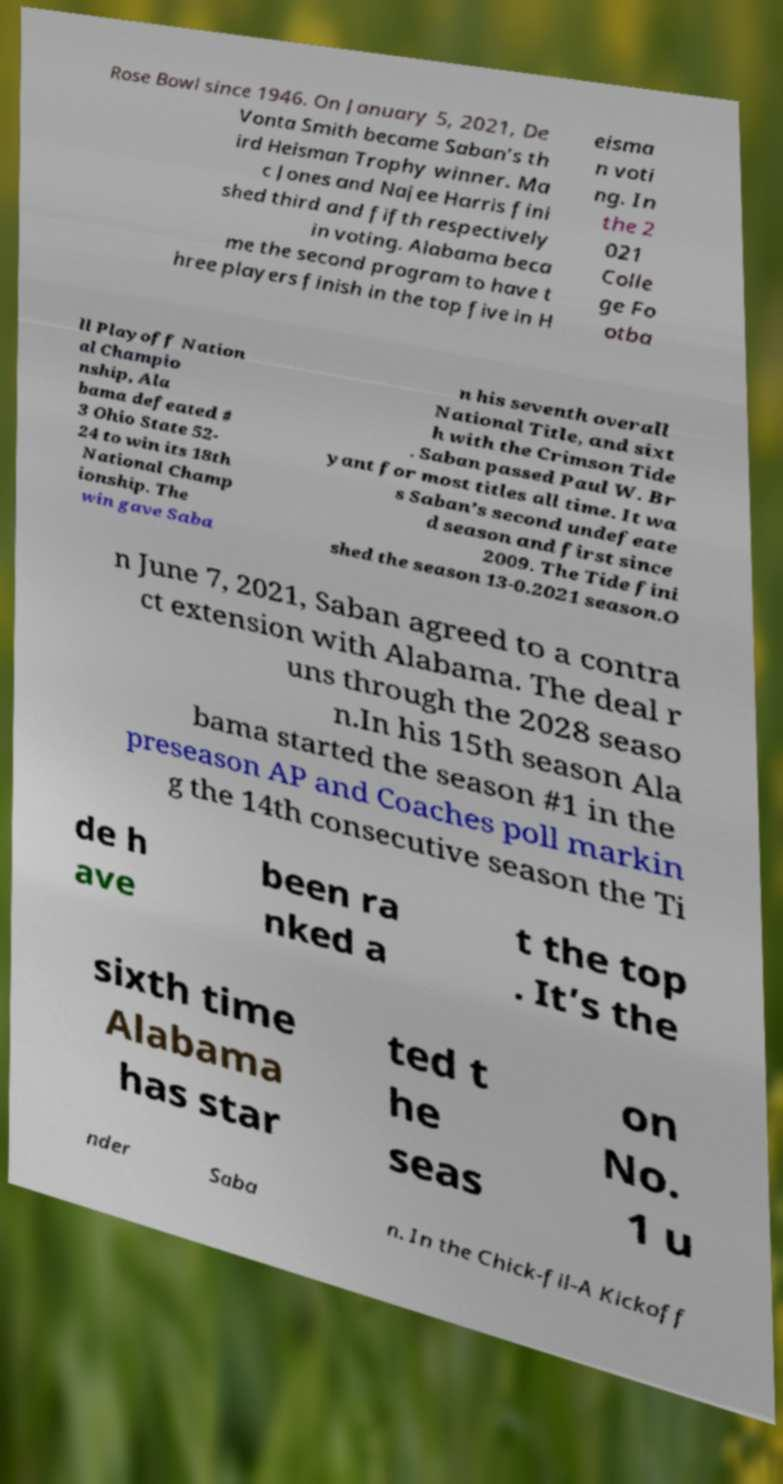Could you extract and type out the text from this image? Rose Bowl since 1946. On January 5, 2021, De Vonta Smith became Saban’s th ird Heisman Trophy winner. Ma c Jones and Najee Harris fini shed third and fifth respectively in voting. Alabama beca me the second program to have t hree players finish in the top five in H eisma n voti ng. In the 2 021 Colle ge Fo otba ll Playoff Nation al Champio nship, Ala bama defeated # 3 Ohio State 52- 24 to win its 18th National Champ ionship. The win gave Saba n his seventh overall National Title, and sixt h with the Crimson Tide . Saban passed Paul W. Br yant for most titles all time. It wa s Saban’s second undefeate d season and first since 2009. The Tide fini shed the season 13-0.2021 season.O n June 7, 2021, Saban agreed to a contra ct extension with Alabama. The deal r uns through the 2028 seaso n.In his 15th season Ala bama started the season #1 in the preseason AP and Coaches poll markin g the 14th consecutive season the Ti de h ave been ra nked a t the top . It’s the sixth time Alabama has star ted t he seas on No. 1 u nder Saba n. In the Chick-fil-A Kickoff 